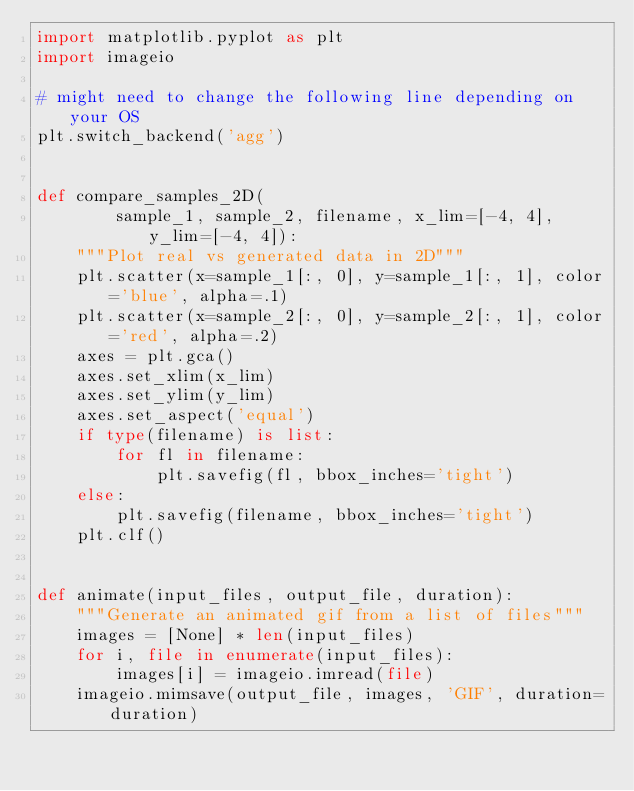<code> <loc_0><loc_0><loc_500><loc_500><_Python_>import matplotlib.pyplot as plt
import imageio

# might need to change the following line depending on your OS
plt.switch_backend('agg')


def compare_samples_2D(
        sample_1, sample_2, filename, x_lim=[-4, 4], y_lim=[-4, 4]):
    """Plot real vs generated data in 2D"""
    plt.scatter(x=sample_1[:, 0], y=sample_1[:, 1], color='blue', alpha=.1)
    plt.scatter(x=sample_2[:, 0], y=sample_2[:, 1], color='red', alpha=.2)
    axes = plt.gca()
    axes.set_xlim(x_lim)
    axes.set_ylim(y_lim)
    axes.set_aspect('equal')
    if type(filename) is list:
        for fl in filename:
            plt.savefig(fl, bbox_inches='tight')
    else:
        plt.savefig(filename, bbox_inches='tight')
    plt.clf()


def animate(input_files, output_file, duration):
    """Generate an animated gif from a list of files"""
    images = [None] * len(input_files)
    for i, file in enumerate(input_files):
        images[i] = imageio.imread(file)
    imageio.mimsave(output_file, images, 'GIF', duration=duration)

</code> 